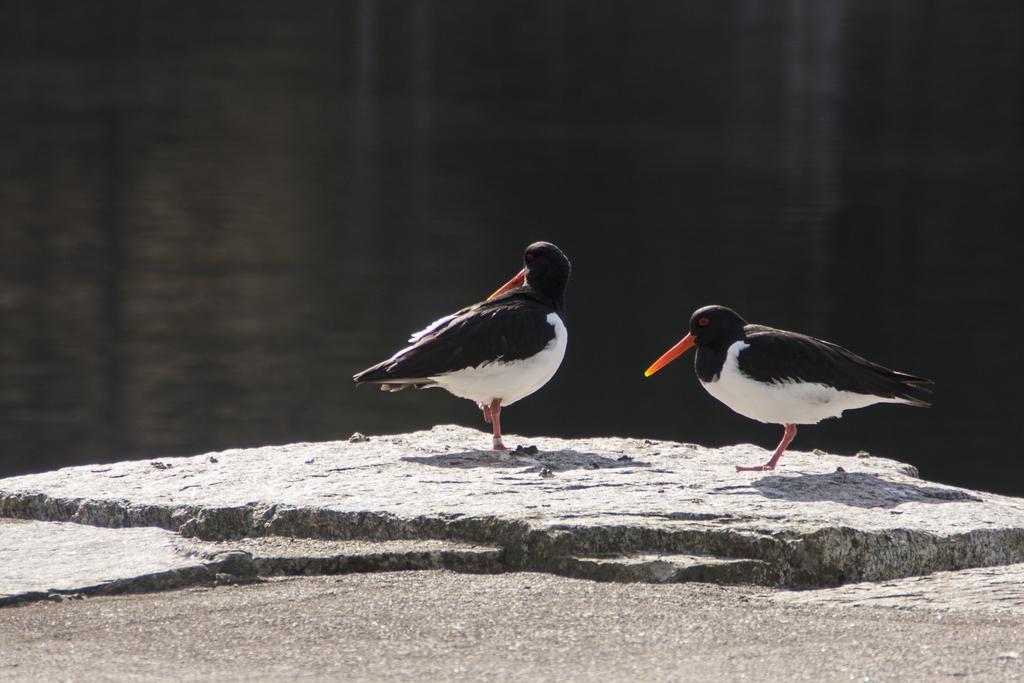Please provide a concise description of this image. In this image we can see birds on a rock. In the back there is water. 